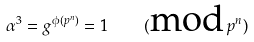<formula> <loc_0><loc_0><loc_500><loc_500>\alpha ^ { 3 } = g ^ { \phi ( p ^ { n } ) } = 1 \quad ( \text {mod} \, p ^ { n } )</formula> 